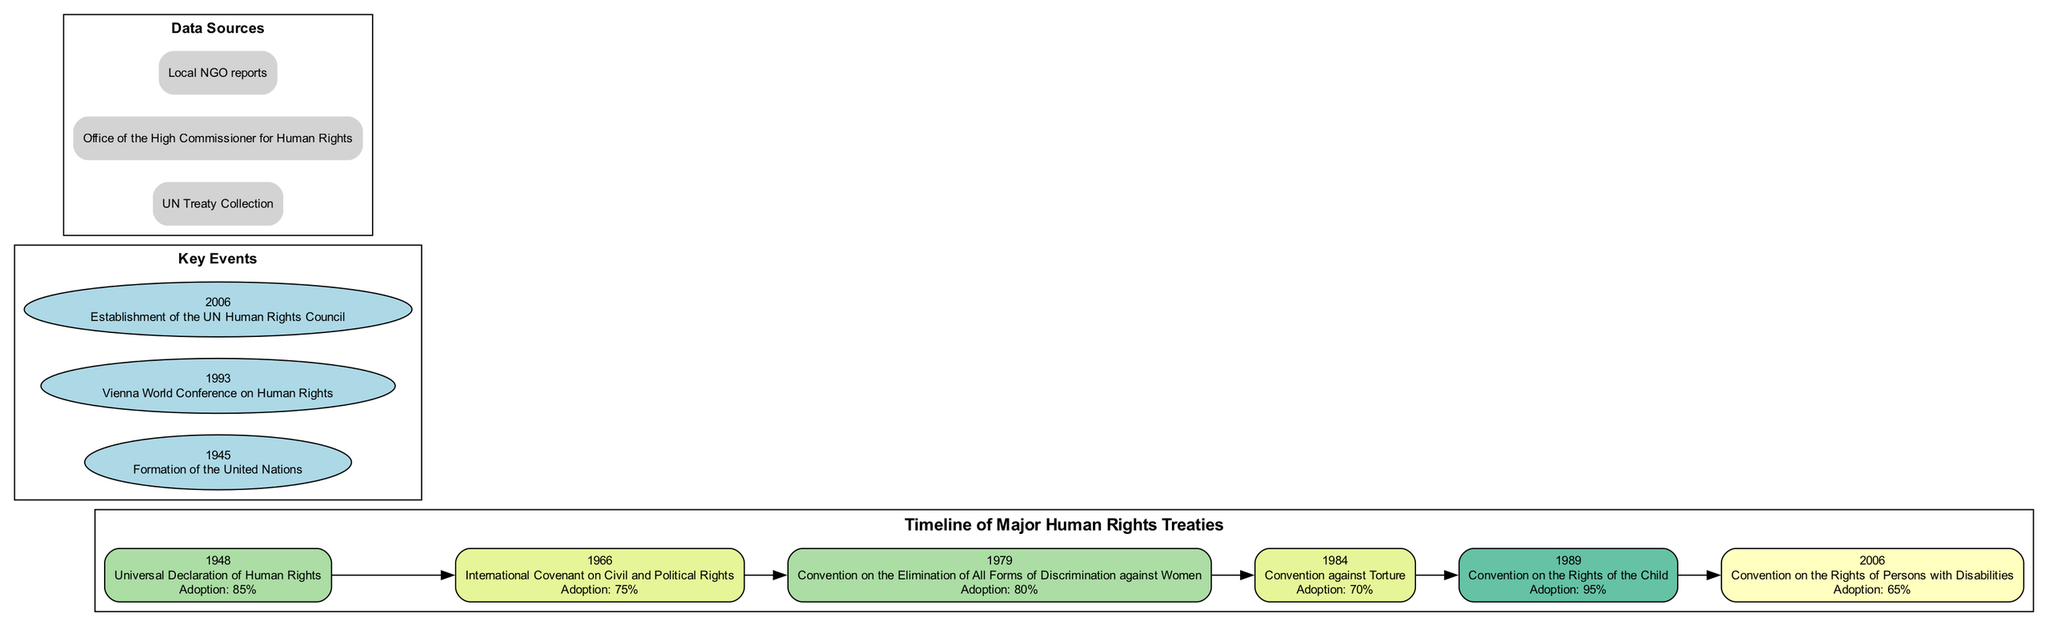What is the adoption rate of the Convention on the Rights of the Child? The adoption rate mentioned in the diagram for the Convention on the Rights of the Child, which was adopted in 1989, is stated directly below the treaty in the timeline.
Answer: 95% In which year was the International Covenant on Civil and Political Rights adopted? To find the year of the International Covenant on Civil and Political Rights, one can locate this treaty's label on the timeline. The corresponding year is shown prominently with the treaty.
Answer: 1966 How many major human rights treaties are listed in the timeline? The total number of treaties can be counted by reviewing each entry within the timeline section of the diagram. There are six entries, each representing a major treaty.
Answer: 6 What major human rights event occurred in 1993? To answer this, one must examine the 'Key Events' section of the diagram for the year 1993. It is explicitly labeled with the event title.
Answer: Vienna World Conference on Human Rights Which treaty has the lowest adoption rate? By examining the adoption rates provided next to each treaty in the timeline, one can compare the values. The lowest rate found is next to the Convention on the Rights of Persons with Disabilities, which is clearly noted in the diagram.
Answer: 65% Which treaty was adopted immediately before the establishment of the UN Human Rights Council? The diagram lists the chronological order of treaties, and the establishment year of the UN Human Rights Council (2006) indicates that the last treaty before it is the Convention on the Rights of Persons with Disabilities from 2006. However, since both were listed as occurring in the same year, no treaty precedes it.
Answer: None What was the adoption rate for the Convention against Torture? The adoption rate can be found directly under the treaty label for the Convention against Torture, which is listed in the timeline. This value can be clearly noted.
Answer: 70% Which node in the timeline corresponds to the highest recorded adoption rate? To determine the highest adoption rate, one reviews all the adoption rates listed next to each treaty. The corresponding node with the highest value is for the Convention on the Rights of the Child, revealing its high adoption.
Answer: Convention on the Rights of the Child What color is used for the node of the Convention on the Elimination of All Forms of Discrimination against Women? The color coding for each node is determined based on their adoption rates. The Convention on the Elimination of All Forms of Discrimination against Women has an adoption rate of 80%, which translates to a specific color on the diagram scale.
Answer: /spectral11/8 